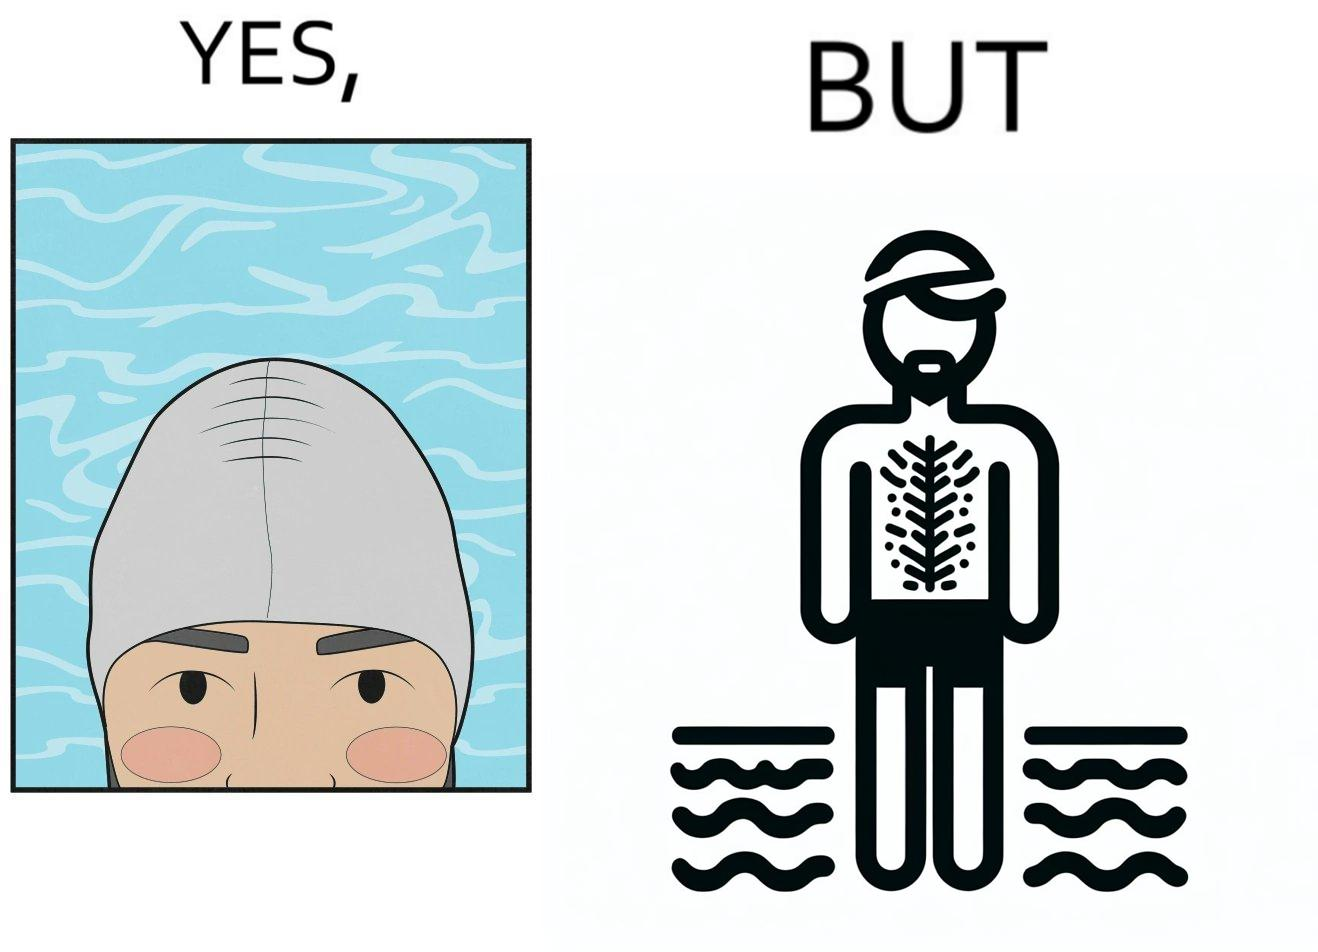What do you see in each half of this image? In the left part of the image: a person's face is shown wearing some cap, probably swimming cap In the right part of the image: a person in shorts wearing a swimming cap standing near some water body, having beard and hairs all over his body 